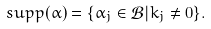Convert formula to latex. <formula><loc_0><loc_0><loc_500><loc_500>s u p p ( \alpha ) = \{ \alpha _ { j } \in \mathcal { B } | k _ { j } \neq { 0 } \} .</formula> 